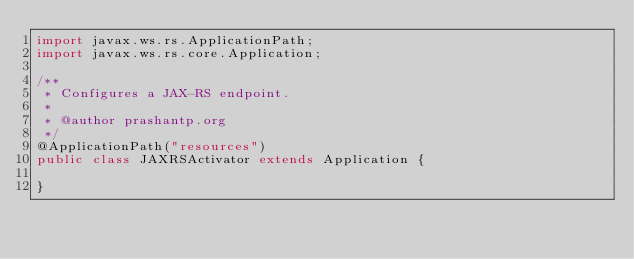<code> <loc_0><loc_0><loc_500><loc_500><_Java_>import javax.ws.rs.ApplicationPath;
import javax.ws.rs.core.Application;

/**
 * Configures a JAX-RS endpoint.
 *
 * @author prashantp.org
 */
@ApplicationPath("resources")
public class JAXRSActivator extends Application {

}
</code> 